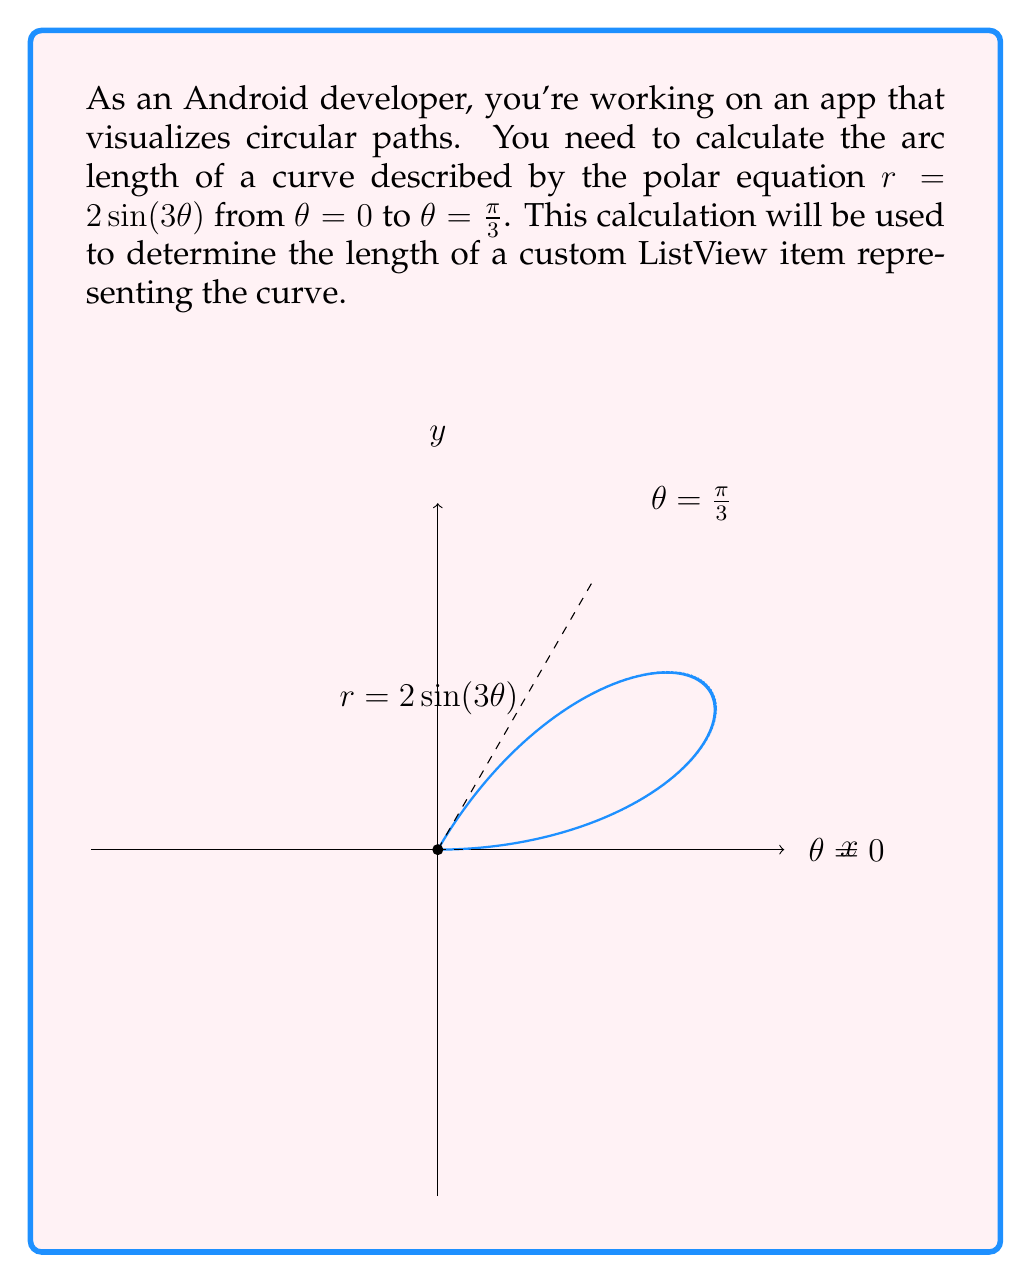What is the answer to this math problem? To calculate the arc length of a curve in polar coordinates, we use the formula:

$$ L = \int_a^b \sqrt{r^2 + \left(\frac{dr}{d\theta}\right)^2} d\theta $$

Where $r$ is the polar equation and $\frac{dr}{d\theta}$ is its derivative with respect to $\theta$.

Step 1: Find $r$ and $\frac{dr}{d\theta}$
$r = 2\sin(3\theta)$
$\frac{dr}{d\theta} = 6\cos(3\theta)$

Step 2: Substitute into the arc length formula
$$ L = \int_0^{\frac{\pi}{3}} \sqrt{(2\sin(3\theta))^2 + (6\cos(3\theta))^2} d\theta $$

Step 3: Simplify the integrand
$$ L = \int_0^{\frac{\pi}{3}} \sqrt{4\sin^2(3\theta) + 36\cos^2(3\theta)} d\theta $$
$$ L = \int_0^{\frac{\pi}{3}} \sqrt{4(\sin^2(3\theta) + 9\cos^2(3\theta))} d\theta $$
$$ L = \int_0^{\frac{\pi}{3}} 2\sqrt{\sin^2(3\theta) + 9\cos^2(3\theta)} d\theta $$

Step 4: Recognize the trigonometric identity $\sin^2(x) + \cos^2(x) = 1$
$\sin^2(3\theta) + 9\cos^2(3\theta) = 9(\frac{1}{9}\sin^2(3\theta) + \cos^2(3\theta)) = 9(\frac{1}{9} + \frac{8}{9}) = 9$

Step 5: Simplify the integral
$$ L = \int_0^{\frac{\pi}{3}} 2\sqrt{9} d\theta = \int_0^{\frac{\pi}{3}} 6 d\theta $$

Step 6: Evaluate the integral
$$ L = 6\theta \bigg|_0^{\frac{\pi}{3}} = 6 \cdot \frac{\pi}{3} - 6 \cdot 0 = 2\pi $$

Therefore, the arc length of the curve is $2\pi$.
Answer: $2\pi$ 